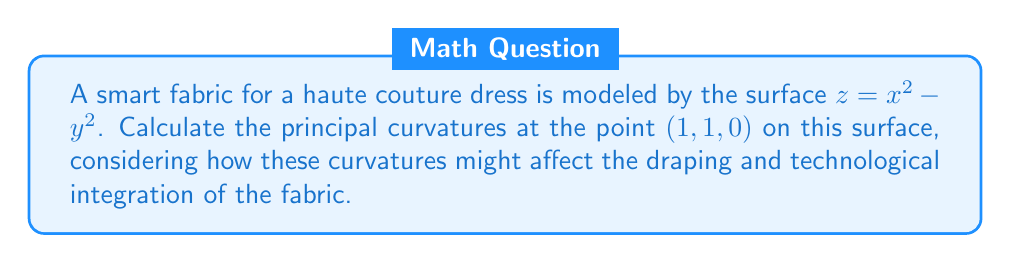Help me with this question. To find the principal curvatures, we'll follow these steps:

1) First, we need to calculate the first and second fundamental forms.

2) The first fundamental form coefficients are:
   $E = 1 + (z_x)^2 = 1 + (2x)^2 = 1 + 4x^2$
   $F = z_x z_y = (2x)(-2y) = -4xy$
   $G = 1 + (z_y)^2 = 1 + (-2y)^2 = 1 + 4y^2$

3) The second fundamental form coefficients are:
   $L = \frac{z_{xx}}{\sqrt{1+z_x^2+z_y^2}} = \frac{2}{\sqrt{1+4x^2+4y^2}}$
   $M = \frac{z_{xy}}{\sqrt{1+z_x^2+z_y^2}} = 0$
   $N = \frac{z_{yy}}{\sqrt{1+z_x^2+z_y^2}} = \frac{-2}{\sqrt{1+4x^2+4y^2}}$

4) At the point (1, 1, 0):
   $E = 5$, $F = -4$, $G = 5$
   $L = \frac{2}{\sqrt{9}} = \frac{2}{3}$, $M = 0$, $N = -\frac{2}{3}$

5) The principal curvatures are the eigenvalues of the shape operator, given by the roots of:

   $$\det\begin{pmatrix} 
   L-\kappa E & M-\kappa F \\
   M-\kappa F & N-\kappa G
   \end{pmatrix} = 0$$

6) Substituting our values:

   $$\det\begin{pmatrix} 
   \frac{2}{3}-5\kappa & -4\kappa \\
   -4\kappa & -\frac{2}{3}-5\kappa
   \end{pmatrix} = 0$$

7) Expanding this determinant:
   $(\frac{2}{3}-5\kappa)(-\frac{2}{3}-5\kappa) - 16\kappa^2 = 0$

8) Simplifying:
   $25\kappa^2 + \frac{10}{3}\kappa - \frac{4}{9} = 0$

9) Solving this quadratic equation:
   $\kappa = \frac{-\frac{10}{3} \pm \sqrt{(\frac{10}{3})^2 + 4(25)(\frac{4}{9})}}{2(25)}$

10) Simplifying further:
    $\kappa = \frac{-\frac{10}{3} \pm \sqrt{\frac{100}{9} + \frac{400}{9}}}{50} = \frac{-\frac{10}{3} \pm \frac{20}{3}}{50}$

Thus, the principal curvatures are:
$\kappa_1 = \frac{1}{15}$ and $\kappa_2 = -\frac{1}{15}$
Answer: $\kappa_1 = \frac{1}{15}$, $\kappa_2 = -\frac{1}{15}$ 